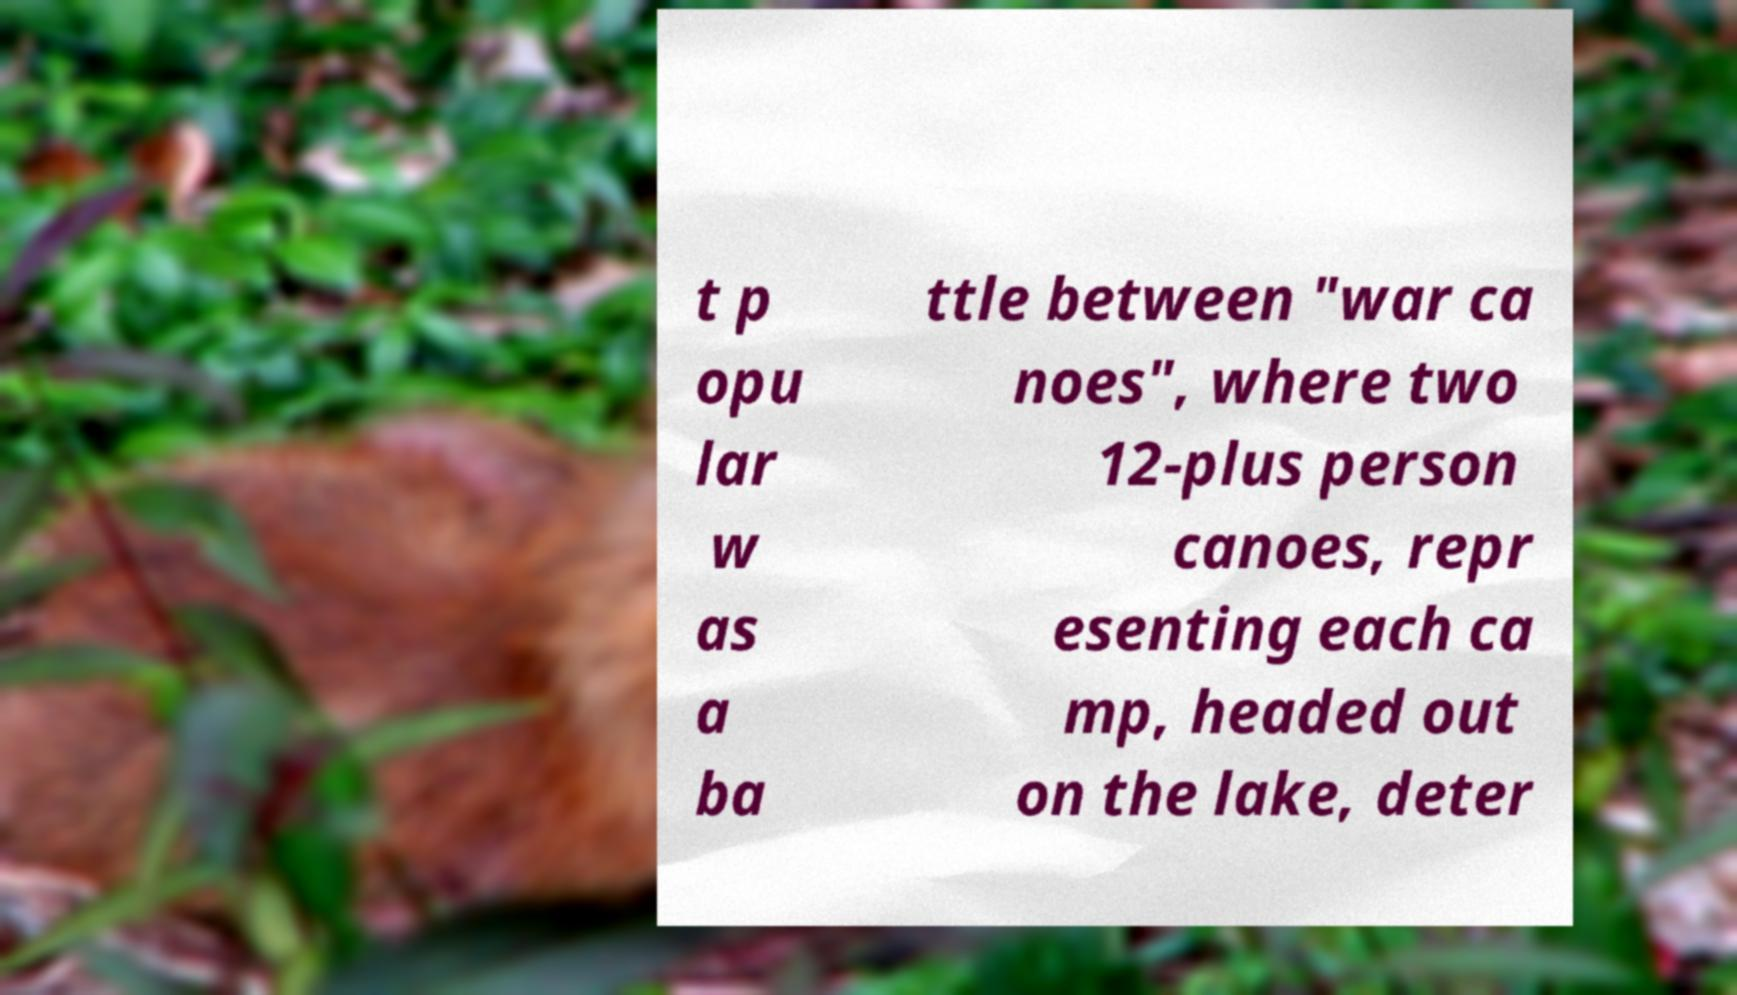Could you extract and type out the text from this image? t p opu lar w as a ba ttle between "war ca noes", where two 12-plus person canoes, repr esenting each ca mp, headed out on the lake, deter 